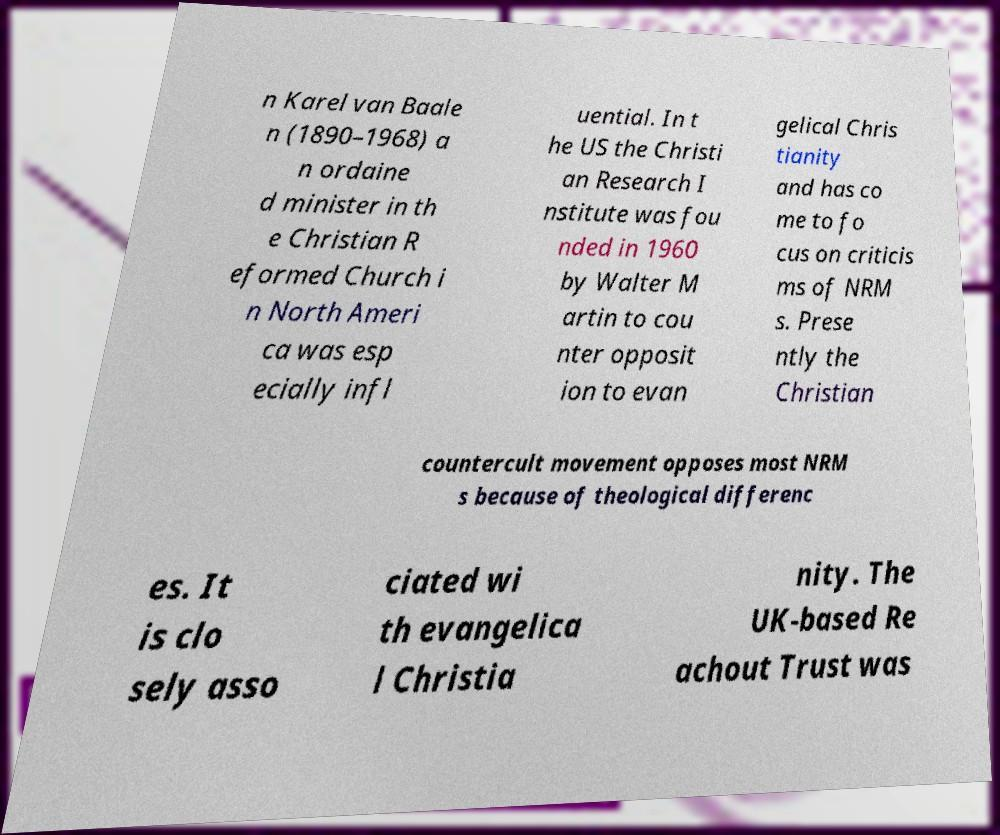For documentation purposes, I need the text within this image transcribed. Could you provide that? n Karel van Baale n (1890–1968) a n ordaine d minister in th e Christian R eformed Church i n North Ameri ca was esp ecially infl uential. In t he US the Christi an Research I nstitute was fou nded in 1960 by Walter M artin to cou nter opposit ion to evan gelical Chris tianity and has co me to fo cus on criticis ms of NRM s. Prese ntly the Christian countercult movement opposes most NRM s because of theological differenc es. It is clo sely asso ciated wi th evangelica l Christia nity. The UK-based Re achout Trust was 